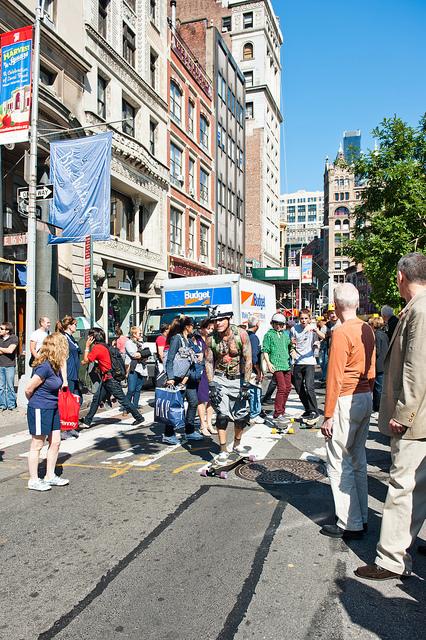Is the street crowded?
Keep it brief. Yes. Is there a moving truck in the picture?
Short answer required. No. What surface are they standing atop?
Be succinct. Street. 